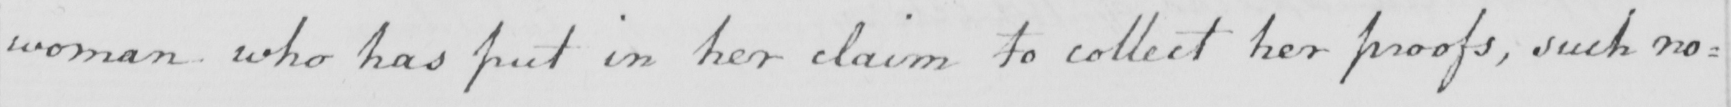Please transcribe the handwritten text in this image. woman who has put in her claim to collect her proofs , such no= 